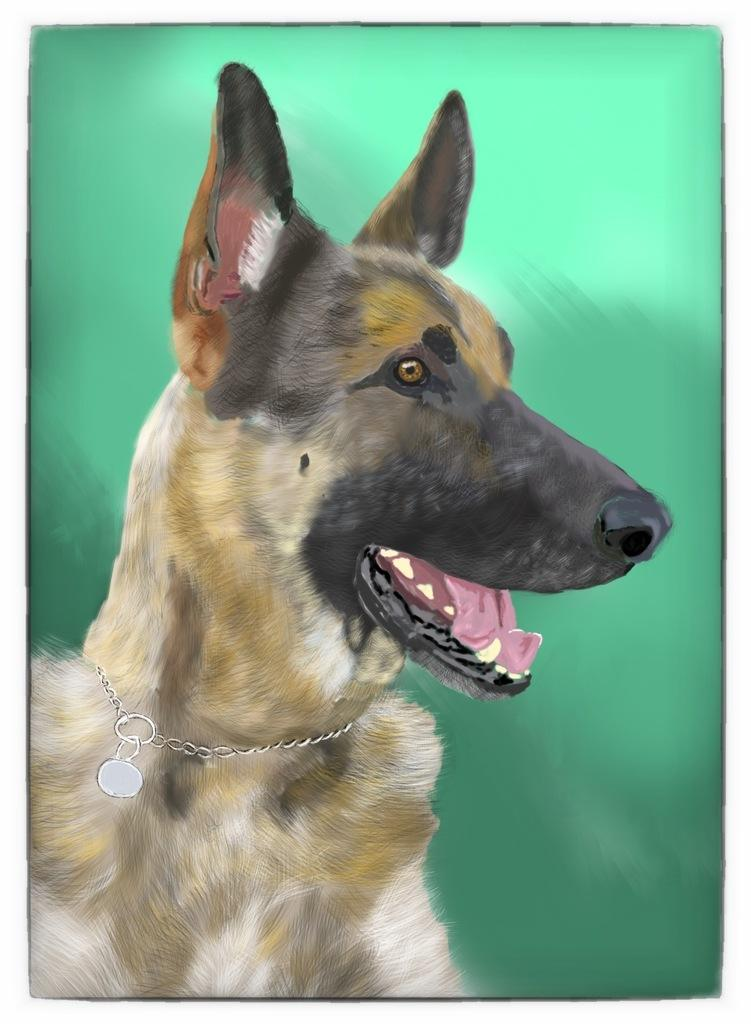What type of artwork is shown in the image? The image is a painting. What animal can be seen in the painting? There is a dog depicted in the painting. What effect does the dog have on the fear of heights in the image? There is no fear of heights mentioned in the image, and the dog does not have any effect on it. 